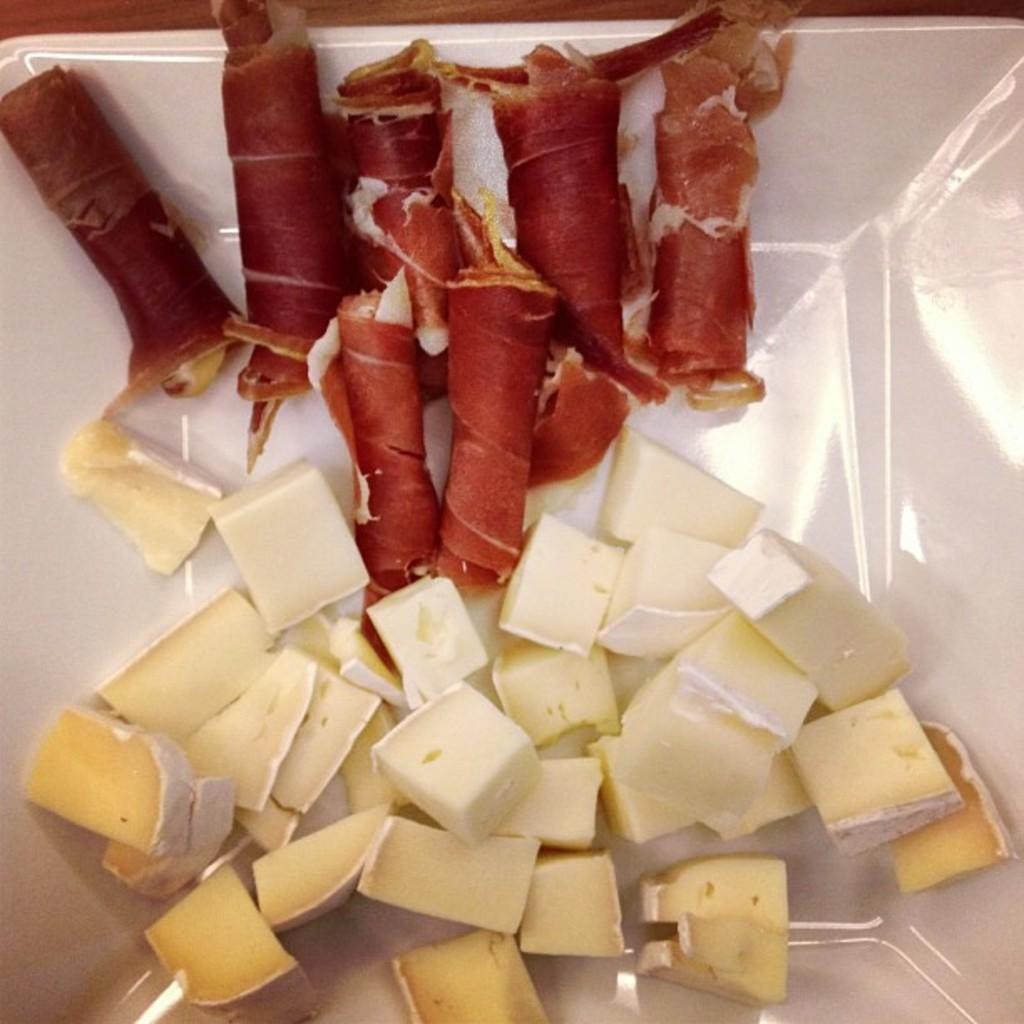What type of food can be seen in the foreground of the image? There are cheese pieces and food rolls in a platter in the foreground of the image. Can you describe the cheese pieces in the image? The cheese pieces are in the foreground of the image. What else is present in the foreground of the image besides the cheese pieces? There are food rolls in a platter in the foreground of the image. What book is the person reading in the image? There is no person or book present in the image; it only features cheese pieces and food rolls in a platter. How many times did the person sneeze before taking the cheese in the image? There is no person present in the image, so it is impossible to determine how many times they sneezed before taking the cheese. 